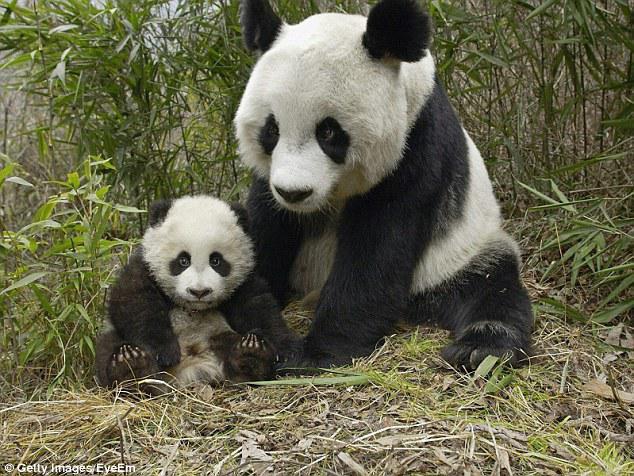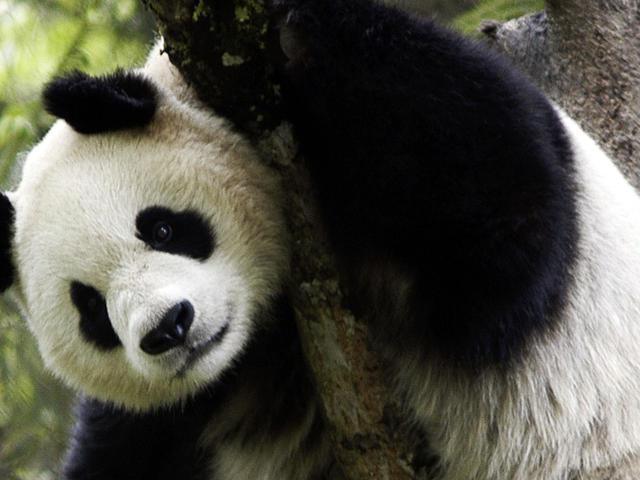The first image is the image on the left, the second image is the image on the right. Given the left and right images, does the statement "There are two panda bears" hold true? Answer yes or no. No. The first image is the image on the left, the second image is the image on the right. For the images shown, is this caption "In one of the images there is a mother panda with her baby." true? Answer yes or no. Yes. 